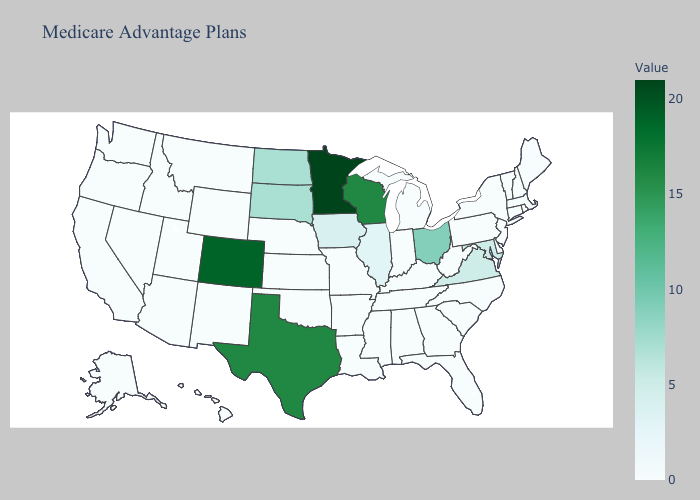Does the map have missing data?
Short answer required. No. Does Washington have the highest value in the West?
Be succinct. No. Does Wisconsin have the lowest value in the USA?
Quick response, please. No. Does Kansas have the highest value in the USA?
Quick response, please. No. Which states have the highest value in the USA?
Be succinct. Minnesota. Does Colorado have the highest value in the West?
Be succinct. Yes. Which states have the lowest value in the South?
Short answer required. Alabama, Arkansas, Delaware, Florida, Georgia, Kentucky, Louisiana, Mississippi, North Carolina, Oklahoma, South Carolina, Tennessee, West Virginia. 